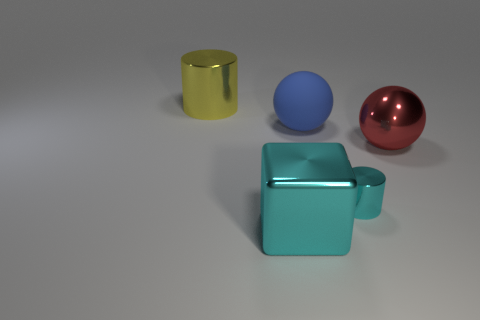Subtract all yellow cylinders. How many cylinders are left? 1 Add 1 large gray cylinders. How many objects exist? 6 Subtract all green spheres. How many red cylinders are left? 0 Subtract all blocks. How many objects are left? 4 Subtract all large blue matte objects. Subtract all blue rubber balls. How many objects are left? 3 Add 4 yellow metallic things. How many yellow metallic things are left? 5 Add 4 small gray things. How many small gray things exist? 4 Subtract 1 cyan blocks. How many objects are left? 4 Subtract 1 blocks. How many blocks are left? 0 Subtract all green cylinders. Subtract all red blocks. How many cylinders are left? 2 